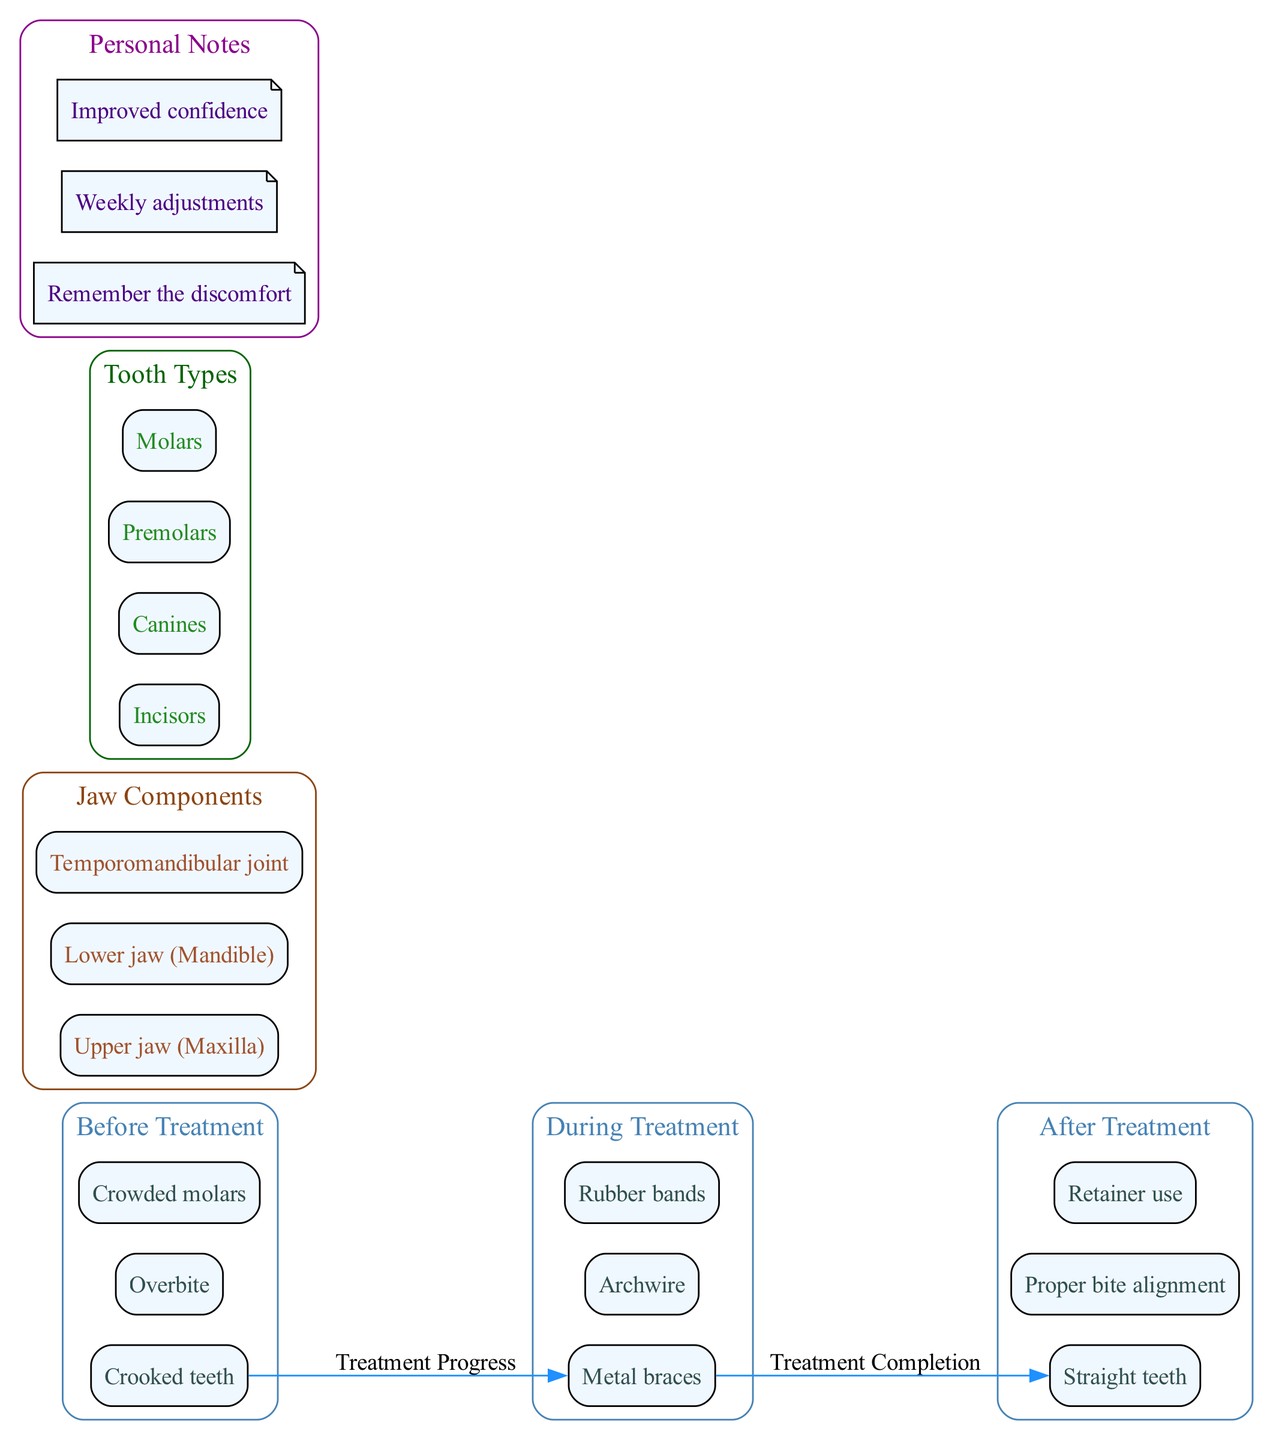What are the features of the "Before Treatment" stage? The "Before Treatment" stage has three features listed: Crooked teeth, Overbite, and Crowded molars. These are described directly under the "Before Treatment" label in the diagram.
Answer: Crooked teeth, Overbite, Crowded molars How many stages are there in the orthodontic treatment process? The diagram outlines three distinct stages: Before Treatment, During Treatment, and After Treatment. Each stage is represented as a separate cluster, making it easy to count.
Answer: 3 What component is listed under Jaw Components? The diagram includes the Upper jaw (Maxilla) as one of the jaw components. This can be found within the "Jaw Components" cluster in the diagram.
Answer: Upper jaw (Maxilla) What type of braces is shown in the "During Treatment" stage? In the "During Treatment" stage, Metal braces are listed as a feature. This can be found directly under the label of that stage in the diagram.
Answer: Metal braces What connects the "Before Treatment" and "During Treatment" stages? The connection between the "Before Treatment" and "During Treatment" stages is indicated by the edge labeled "Treatment Progress". This shows the flow from one stage to the next in the diagram.
Answer: Treatment Progress What is the personal note highlighting improvement during treatment? One of the personal notes states "Improved confidence" which reflects the positive outcome after orthodontic treatment. This note is found in the "Personal Notes" cluster.
Answer: Improved confidence How many different types of teeth are represented in the diagram? The diagram displays a total of four different types of teeth: Incisors, Canines, Premolars, and Molars, each categorized under their own cluster. This can be counted directly from the "Tooth Types" section.
Answer: 4 What feature indicates a proper bite after treatment? The feature "Proper bite alignment" is highlighted in the "After Treatment" stage, indicating the successful outcome of orthodontic treatment in relation to bite alignment.
Answer: Proper bite alignment What is the relationship between the "During Treatment" and "After Treatment" stages? The relationship is depicted as "Treatment Completion", indicating a flow from the "During Treatment" to "After Treatment". This edge can be seen connecting the two stages in the diagram.
Answer: Treatment Completion 